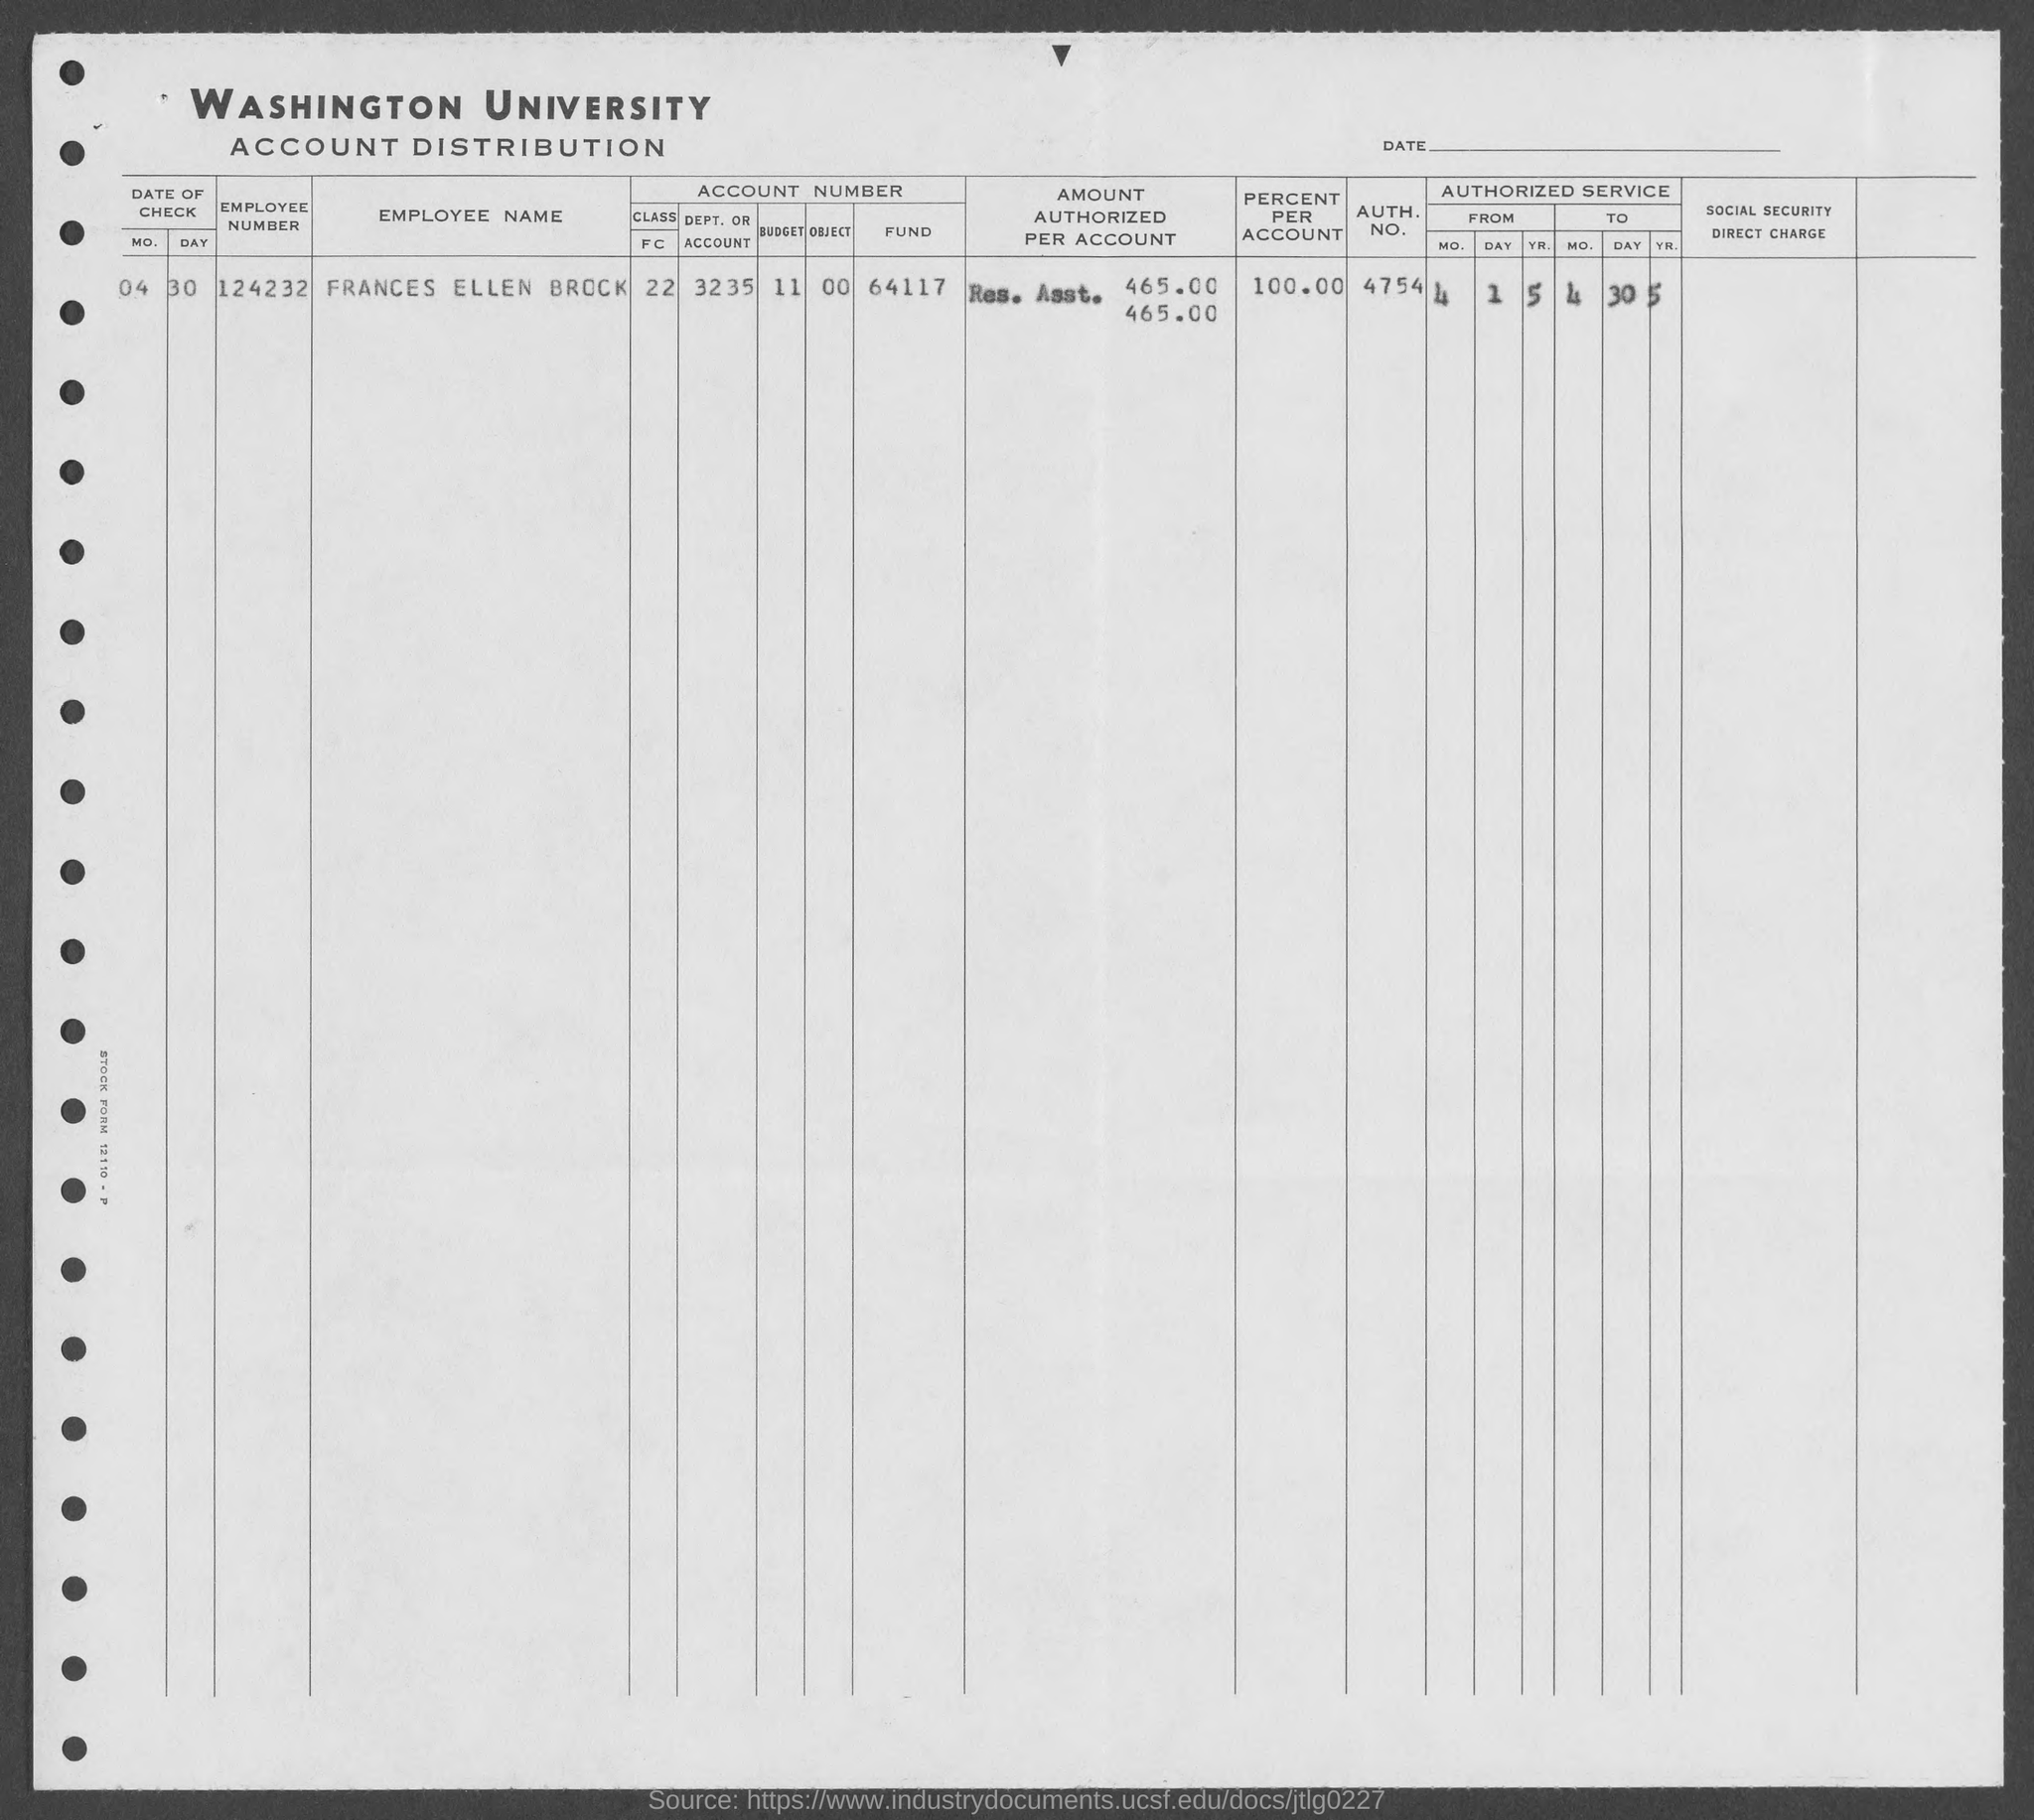Mention a couple of crucial points in this snapshot. What is the object number mentioned in the given form? It is 00.. The name of the employee mentioned in the given form is Frances Ellen Brock. What is the employee number mentioned in the given form? It is 124232. The budget number mentioned in the given form is 11. The value of the percentage, as mentioned in the provided form, is 100.00%. 